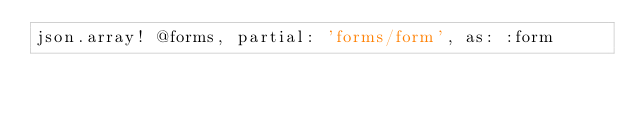Convert code to text. <code><loc_0><loc_0><loc_500><loc_500><_Ruby_>json.array! @forms, partial: 'forms/form', as: :form</code> 